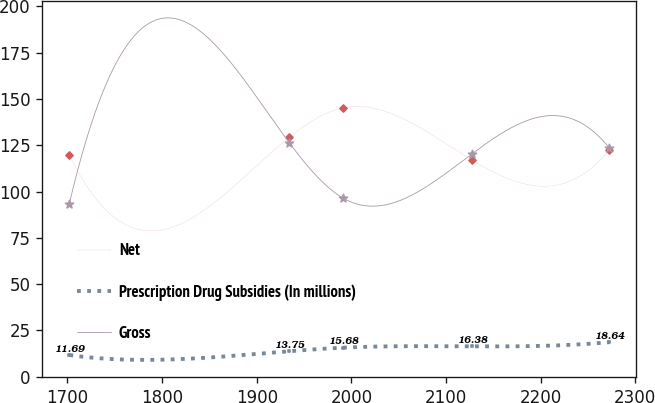Convert chart to OTSL. <chart><loc_0><loc_0><loc_500><loc_500><line_chart><ecel><fcel>Net<fcel>Prescription Drug Subsidies (In millions)<fcel>Gross<nl><fcel>1701.94<fcel>119.8<fcel>11.69<fcel>93.47<nl><fcel>1934.31<fcel>129.33<fcel>13.75<fcel>126.45<nl><fcel>1991.39<fcel>145.24<fcel>15.68<fcel>96.43<nl><fcel>2127.81<fcel>116.97<fcel>16.38<fcel>120.53<nl><fcel>2272.72<fcel>122.63<fcel>18.64<fcel>123.49<nl></chart> 